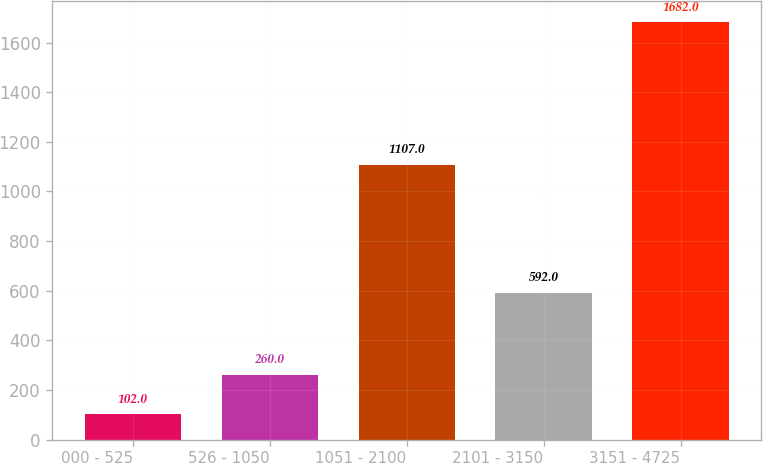Convert chart. <chart><loc_0><loc_0><loc_500><loc_500><bar_chart><fcel>000 - 525<fcel>526 - 1050<fcel>1051 - 2100<fcel>2101 - 3150<fcel>3151 - 4725<nl><fcel>102<fcel>260<fcel>1107<fcel>592<fcel>1682<nl></chart> 